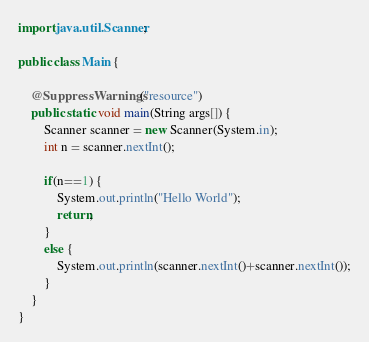Convert code to text. <code><loc_0><loc_0><loc_500><loc_500><_Java_>import java.util.Scanner;

public class Main {

	@SuppressWarnings("resource")
	public static void main(String args[]) {
		Scanner scanner = new Scanner(System.in);
		int n = scanner.nextInt();
		
		if(n==1) {
			System.out.println("Hello World");
			return;
		}
		else {
			System.out.println(scanner.nextInt()+scanner.nextInt());
		}
	}
}
</code> 